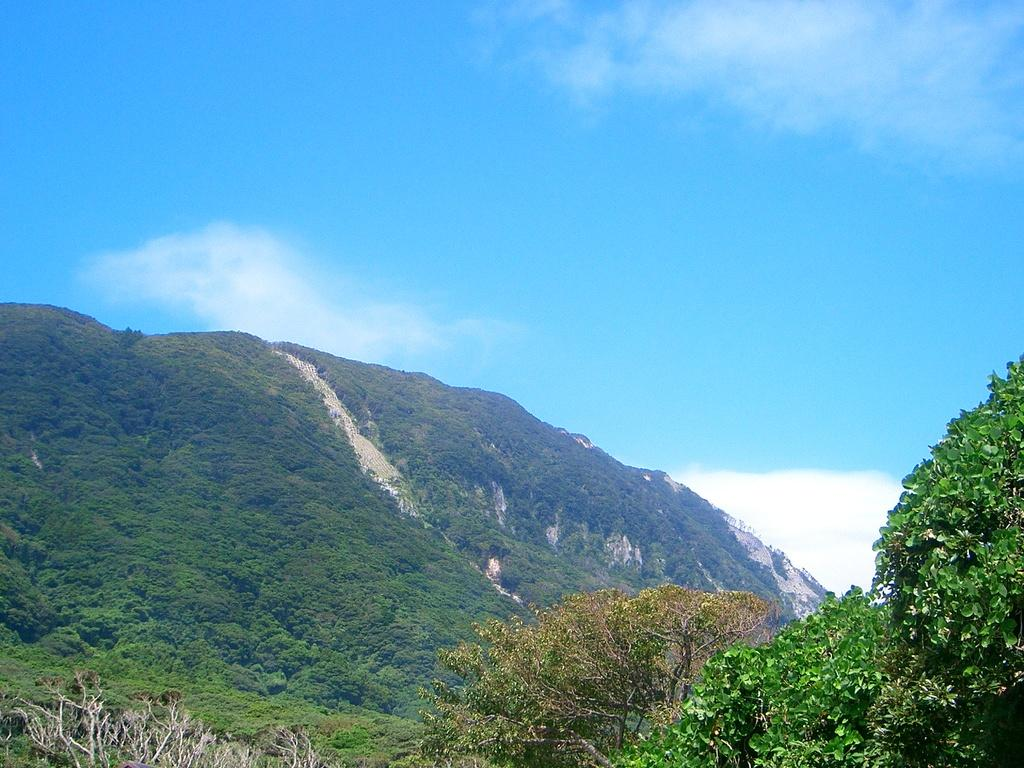What type of landscape can be seen in the image? There are hills in the image. What type of vegetation is present in the image? There are trees and plants in the image. What is visible in the background of the image? The sky is visible in the image. What color of chalk is being used to draw on the trees in the image? There is no chalk or drawing activity present in the image; it features natural landscape elements. 